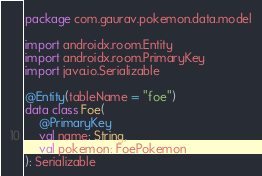<code> <loc_0><loc_0><loc_500><loc_500><_Kotlin_>package com.gaurav.pokemon.data.model

import androidx.room.Entity
import androidx.room.PrimaryKey
import java.io.Serializable

@Entity(tableName = "foe")
data class Foe(
    @PrimaryKey
    val name: String,
    val pokemon: FoePokemon
): Serializable</code> 